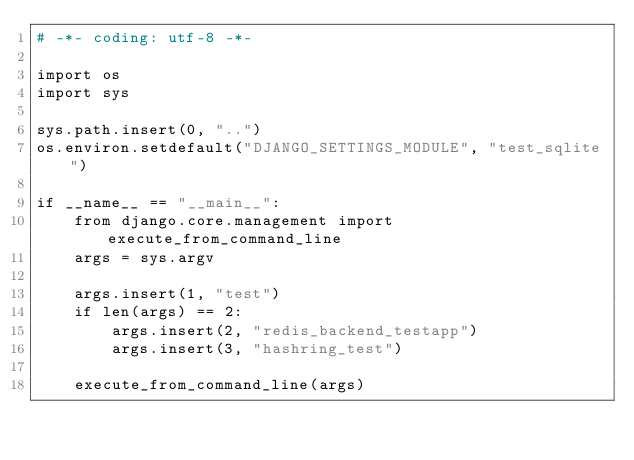<code> <loc_0><loc_0><loc_500><loc_500><_Python_># -*- coding: utf-8 -*-

import os
import sys

sys.path.insert(0, "..")
os.environ.setdefault("DJANGO_SETTINGS_MODULE", "test_sqlite")

if __name__ == "__main__":
    from django.core.management import execute_from_command_line
    args = sys.argv

    args.insert(1, "test")
    if len(args) == 2:
        args.insert(2, "redis_backend_testapp")
        args.insert(3, "hashring_test")

    execute_from_command_line(args)
</code> 